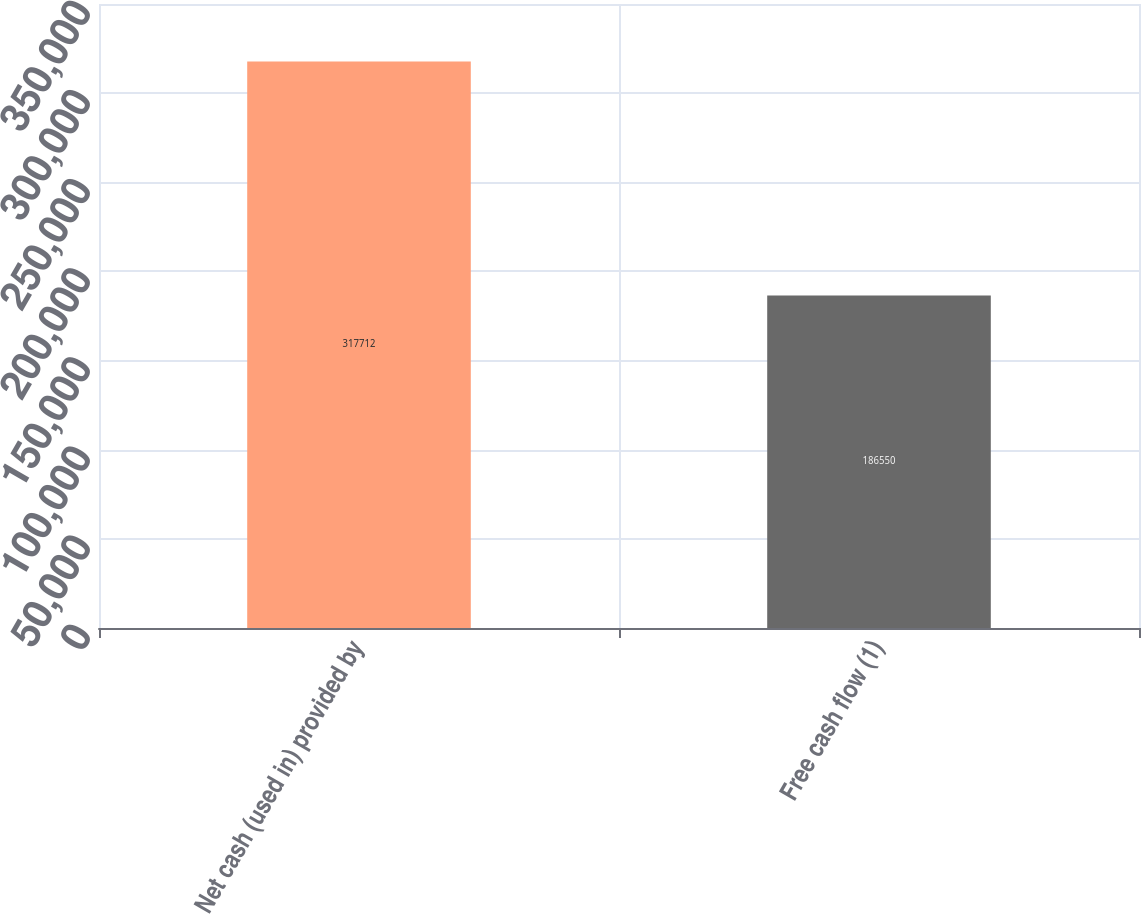Convert chart. <chart><loc_0><loc_0><loc_500><loc_500><bar_chart><fcel>Net cash (used in) provided by<fcel>Free cash flow (1)<nl><fcel>317712<fcel>186550<nl></chart> 